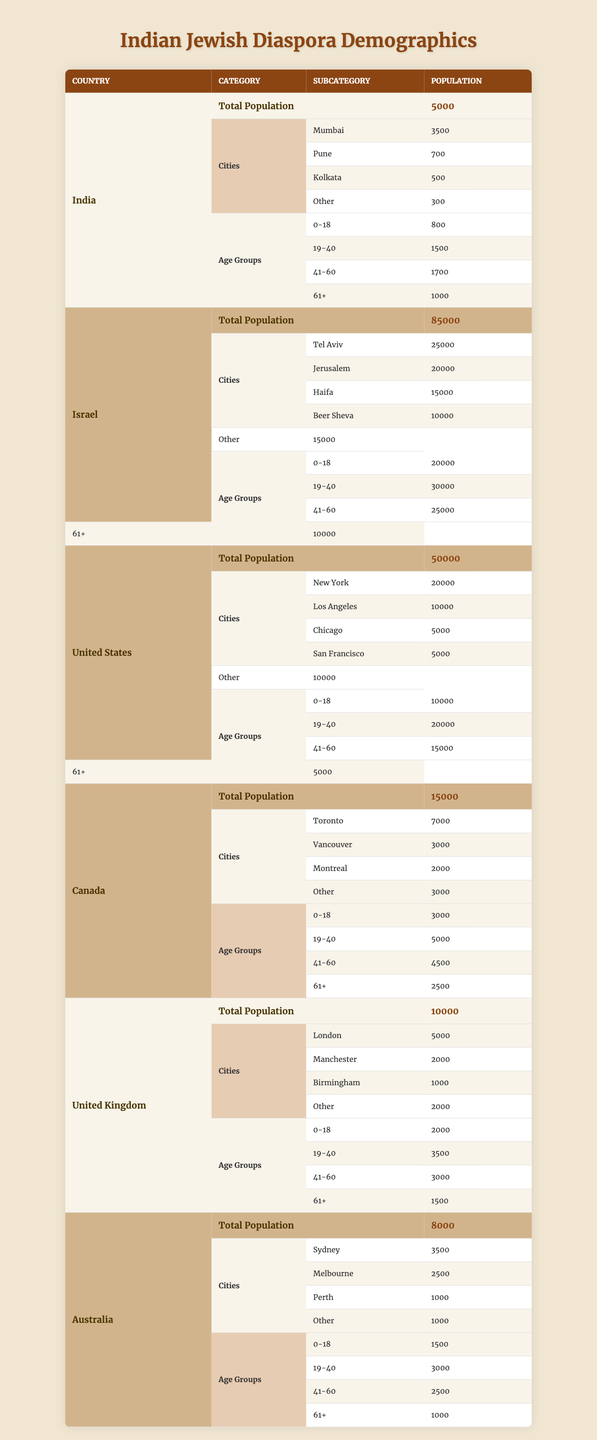What is the total population of Indian Jews in Canada? The table shows that the total population of Indian Jews in Canada is 15,000.
Answer: 15,000 Which city has the highest Indian Jewish population in Israel? According to the table, Tel Aviv has the highest Indian Jewish population, with 25,000 individuals.
Answer: Tel Aviv What is the combined population of Indian Jews in Australia and the United Kingdom? To find the combined population, we add Australia's population (8,000) and the UK's population (10,000); thus, 8,000 + 10,000 = 18,000.
Answer: 18,000 What age group has the largest population in the United States? The largest age group in the United States is 19-40 years, with a population of 20,000.
Answer: 19-40 years Is the total population of Indian Jews in Israel greater than that in the United States? Yes, Israel has a total population of 85,000, which exceeds the 50,000 population in the United States.
Answer: Yes How many Indian Jews are aged 61 or older in India? The table indicates that in India, there are 1,000 individuals aged 61 or older.
Answer: 1,000 What is the average population of Indian Jews across the five countries mentioned? The populations of Indian Jews in the five countries are India (5,000), Israel (85,000), the United States (50,000), Canada (15,000), and the United Kingdom (10,000). The average is calculated as (5,000 + 85,000 + 50,000 + 15,000 + 10,000) / 5 = 33,000.
Answer: 33,000 What percentage of the total Indian Jewish population in the United States is under 18 years old? The under 18 population in the United States is 10,000 out of a total of 50,000; therefore, the percentage is (10,000 / 50,000) * 100 = 20%.
Answer: 20% How many Indian Jews live in cities other than the major ones mentioned in Australia? The table states that there are 1,000 Indian Jews in cities categorized as "Other" in Australia.
Answer: 1,000 Which age group has the lowest number in the United Kingdom? In the United Kingdom, the age group with the lowest number is 61+, containing 1,500 individuals.
Answer: 61+ Is the population of Indian Jews more concentrated in Mumbai compared to Toronto? Yes, Mumbai has a population of 3,500 while Toronto has 7,000, making Toronto more populated. The question implies a misunderstanding, hence the answer is no.
Answer: No 